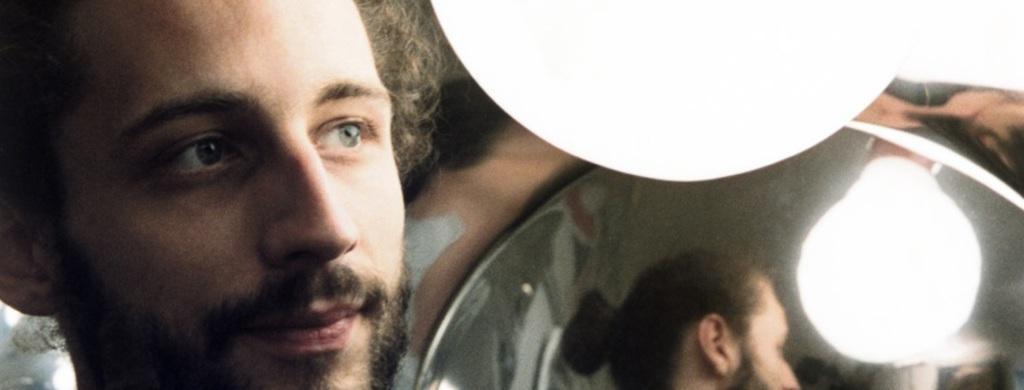Please provide a concise description of this image. This image consists of a man. On the right, we can see a mirror along with a light. 